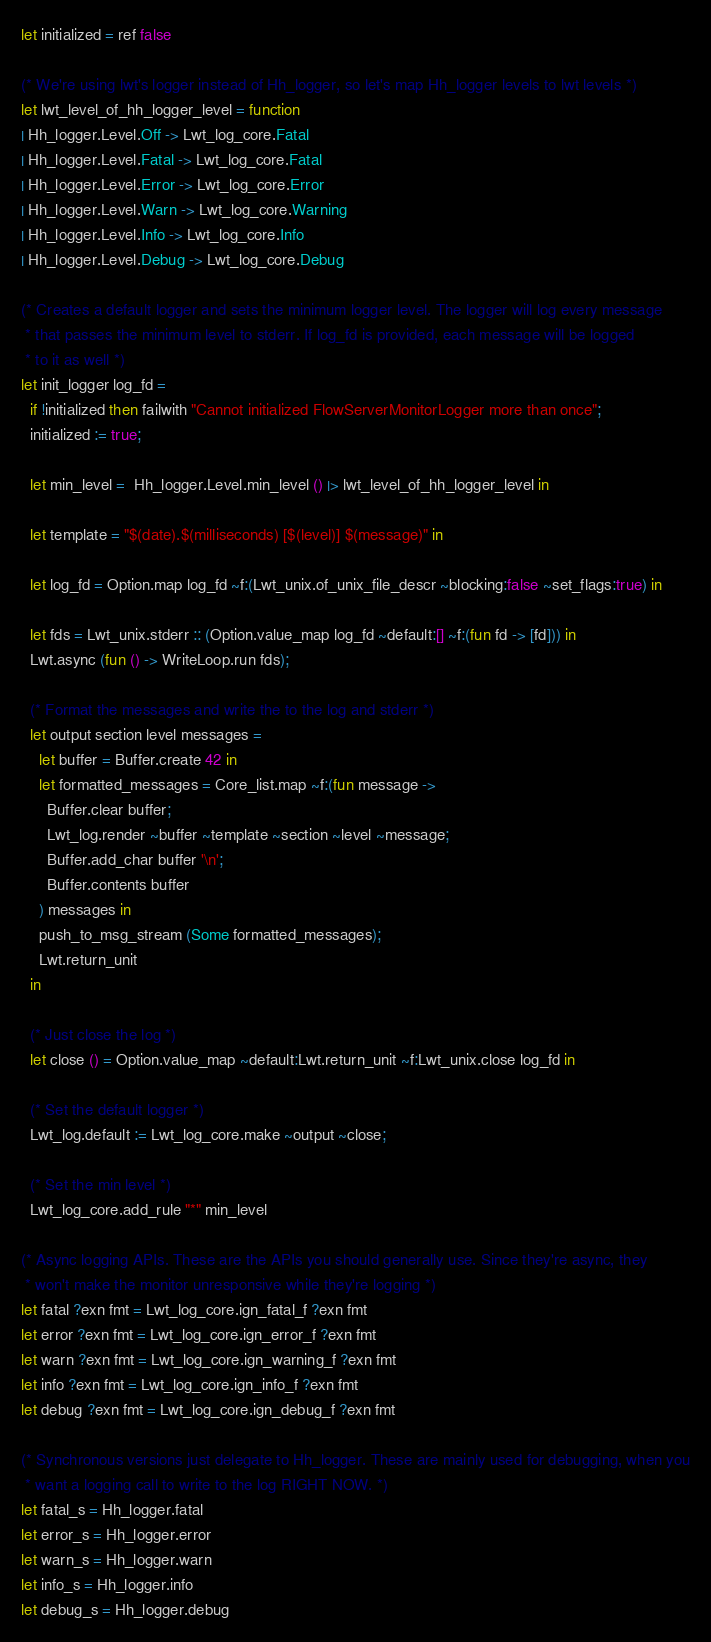<code> <loc_0><loc_0><loc_500><loc_500><_OCaml_>
let initialized = ref false

(* We're using lwt's logger instead of Hh_logger, so let's map Hh_logger levels to lwt levels *)
let lwt_level_of_hh_logger_level = function
| Hh_logger.Level.Off -> Lwt_log_core.Fatal
| Hh_logger.Level.Fatal -> Lwt_log_core.Fatal
| Hh_logger.Level.Error -> Lwt_log_core.Error
| Hh_logger.Level.Warn -> Lwt_log_core.Warning
| Hh_logger.Level.Info -> Lwt_log_core.Info
| Hh_logger.Level.Debug -> Lwt_log_core.Debug

(* Creates a default logger and sets the minimum logger level. The logger will log every message
 * that passes the minimum level to stderr. If log_fd is provided, each message will be logged
 * to it as well *)
let init_logger log_fd =
  if !initialized then failwith "Cannot initialized FlowServerMonitorLogger more than once";
  initialized := true;

  let min_level =  Hh_logger.Level.min_level () |> lwt_level_of_hh_logger_level in

  let template = "$(date).$(milliseconds) [$(level)] $(message)" in

  let log_fd = Option.map log_fd ~f:(Lwt_unix.of_unix_file_descr ~blocking:false ~set_flags:true) in

  let fds = Lwt_unix.stderr :: (Option.value_map log_fd ~default:[] ~f:(fun fd -> [fd])) in
  Lwt.async (fun () -> WriteLoop.run fds);

  (* Format the messages and write the to the log and stderr *)
  let output section level messages =
    let buffer = Buffer.create 42 in
    let formatted_messages = Core_list.map ~f:(fun message ->
      Buffer.clear buffer;
      Lwt_log.render ~buffer ~template ~section ~level ~message;
      Buffer.add_char buffer '\n';
      Buffer.contents buffer
    ) messages in
    push_to_msg_stream (Some formatted_messages);
    Lwt.return_unit
  in

  (* Just close the log *)
  let close () = Option.value_map ~default:Lwt.return_unit ~f:Lwt_unix.close log_fd in

  (* Set the default logger *)
  Lwt_log.default := Lwt_log_core.make ~output ~close;

  (* Set the min level *)
  Lwt_log_core.add_rule "*" min_level

(* Async logging APIs. These are the APIs you should generally use. Since they're async, they
 * won't make the monitor unresponsive while they're logging *)
let fatal ?exn fmt = Lwt_log_core.ign_fatal_f ?exn fmt
let error ?exn fmt = Lwt_log_core.ign_error_f ?exn fmt
let warn ?exn fmt = Lwt_log_core.ign_warning_f ?exn fmt
let info ?exn fmt = Lwt_log_core.ign_info_f ?exn fmt
let debug ?exn fmt = Lwt_log_core.ign_debug_f ?exn fmt

(* Synchronous versions just delegate to Hh_logger. These are mainly used for debugging, when you
 * want a logging call to write to the log RIGHT NOW. *)
let fatal_s = Hh_logger.fatal
let error_s = Hh_logger.error
let warn_s = Hh_logger.warn
let info_s = Hh_logger.info
let debug_s = Hh_logger.debug
</code> 